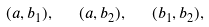Convert formula to latex. <formula><loc_0><loc_0><loc_500><loc_500>( a , b _ { 1 } ) , \text { \ \ } ( a , b _ { 2 } ) , \text { \ \ } ( b _ { 1 } , b _ { 2 } ) ,</formula> 